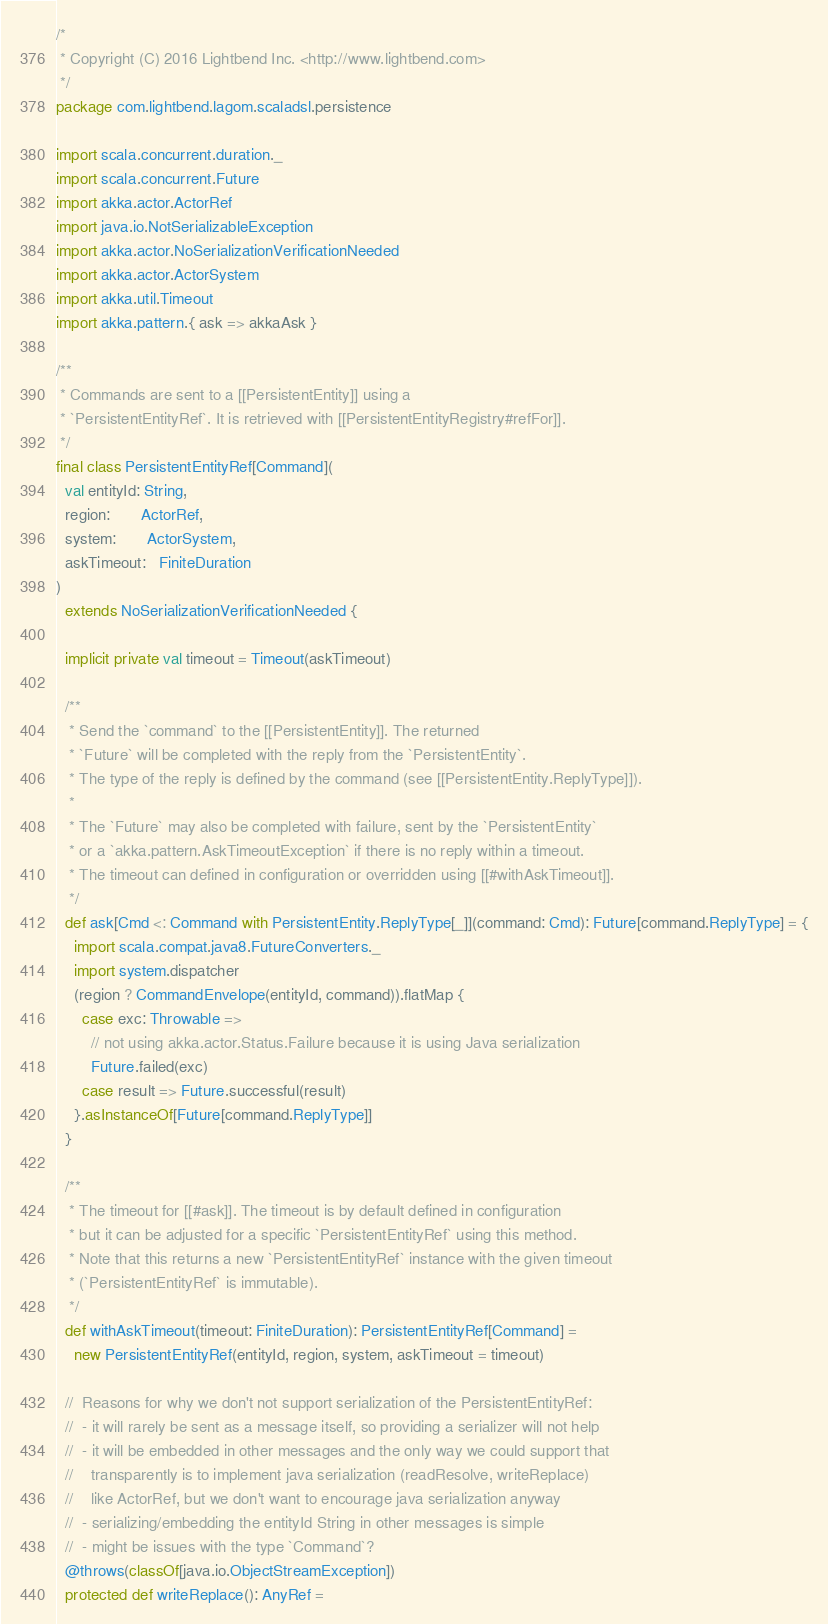Convert code to text. <code><loc_0><loc_0><loc_500><loc_500><_Scala_>/*
 * Copyright (C) 2016 Lightbend Inc. <http://www.lightbend.com>
 */
package com.lightbend.lagom.scaladsl.persistence

import scala.concurrent.duration._
import scala.concurrent.Future
import akka.actor.ActorRef
import java.io.NotSerializableException
import akka.actor.NoSerializationVerificationNeeded
import akka.actor.ActorSystem
import akka.util.Timeout
import akka.pattern.{ ask => akkaAsk }

/**
 * Commands are sent to a [[PersistentEntity]] using a
 * `PersistentEntityRef`. It is retrieved with [[PersistentEntityRegistry#refFor]].
 */
final class PersistentEntityRef[Command](
  val entityId: String,
  region:       ActorRef,
  system:       ActorSystem,
  askTimeout:   FiniteDuration
)
  extends NoSerializationVerificationNeeded {

  implicit private val timeout = Timeout(askTimeout)

  /**
   * Send the `command` to the [[PersistentEntity]]. The returned
   * `Future` will be completed with the reply from the `PersistentEntity`.
   * The type of the reply is defined by the command (see [[PersistentEntity.ReplyType]]).
   *
   * The `Future` may also be completed with failure, sent by the `PersistentEntity`
   * or a `akka.pattern.AskTimeoutException` if there is no reply within a timeout.
   * The timeout can defined in configuration or overridden using [[#withAskTimeout]].
   */
  def ask[Cmd <: Command with PersistentEntity.ReplyType[_]](command: Cmd): Future[command.ReplyType] = {
    import scala.compat.java8.FutureConverters._
    import system.dispatcher
    (region ? CommandEnvelope(entityId, command)).flatMap {
      case exc: Throwable =>
        // not using akka.actor.Status.Failure because it is using Java serialization
        Future.failed(exc)
      case result => Future.successful(result)
    }.asInstanceOf[Future[command.ReplyType]]
  }

  /**
   * The timeout for [[#ask]]. The timeout is by default defined in configuration
   * but it can be adjusted for a specific `PersistentEntityRef` using this method.
   * Note that this returns a new `PersistentEntityRef` instance with the given timeout
   * (`PersistentEntityRef` is immutable).
   */
  def withAskTimeout(timeout: FiniteDuration): PersistentEntityRef[Command] =
    new PersistentEntityRef(entityId, region, system, askTimeout = timeout)

  //  Reasons for why we don't not support serialization of the PersistentEntityRef:
  //  - it will rarely be sent as a message itself, so providing a serializer will not help
  //  - it will be embedded in other messages and the only way we could support that
  //    transparently is to implement java serialization (readResolve, writeReplace)
  //    like ActorRef, but we don't want to encourage java serialization anyway
  //  - serializing/embedding the entityId String in other messages is simple
  //  - might be issues with the type `Command`?
  @throws(classOf[java.io.ObjectStreamException])
  protected def writeReplace(): AnyRef =</code> 